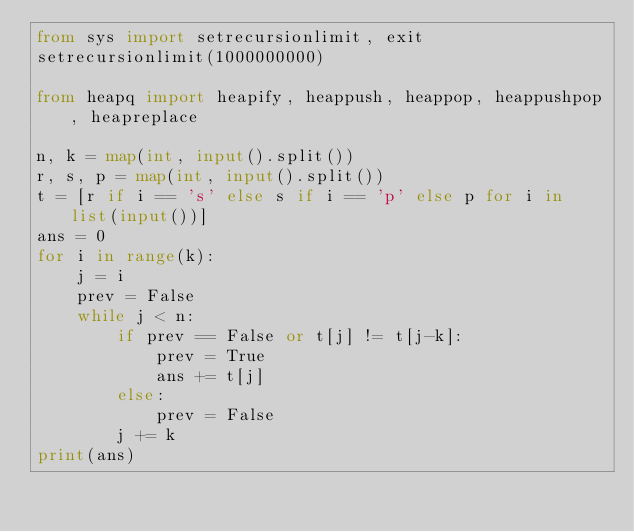<code> <loc_0><loc_0><loc_500><loc_500><_Python_>from sys import setrecursionlimit, exit
setrecursionlimit(1000000000)

from heapq import heapify, heappush, heappop, heappushpop, heapreplace

n, k = map(int, input().split())
r, s, p = map(int, input().split())
t = [r if i == 's' else s if i == 'p' else p for i in list(input())]
ans = 0
for i in range(k):
    j = i
    prev = False
    while j < n:
        if prev == False or t[j] != t[j-k]:
            prev = True
            ans += t[j]
        else:
            prev = False
        j += k
print(ans)</code> 